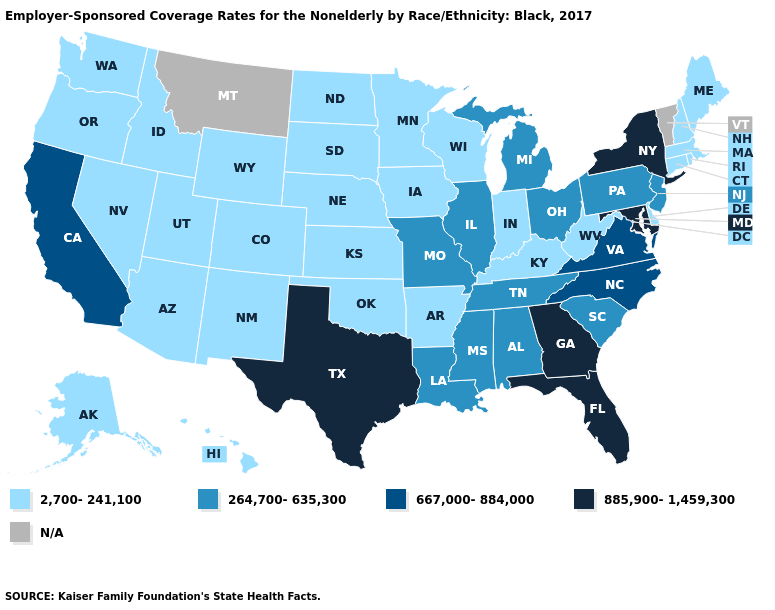Does Tennessee have the highest value in the USA?
Be succinct. No. Which states have the lowest value in the West?
Write a very short answer. Alaska, Arizona, Colorado, Hawaii, Idaho, Nevada, New Mexico, Oregon, Utah, Washington, Wyoming. Among the states that border Missouri , which have the lowest value?
Be succinct. Arkansas, Iowa, Kansas, Kentucky, Nebraska, Oklahoma. What is the lowest value in the MidWest?
Be succinct. 2,700-241,100. What is the highest value in the USA?
Concise answer only. 885,900-1,459,300. Does the map have missing data?
Concise answer only. Yes. What is the value of New Mexico?
Write a very short answer. 2,700-241,100. Among the states that border Colorado , which have the lowest value?
Be succinct. Arizona, Kansas, Nebraska, New Mexico, Oklahoma, Utah, Wyoming. Which states have the lowest value in the West?
Quick response, please. Alaska, Arizona, Colorado, Hawaii, Idaho, Nevada, New Mexico, Oregon, Utah, Washington, Wyoming. Does Colorado have the lowest value in the West?
Short answer required. Yes. Which states have the lowest value in the USA?
Keep it brief. Alaska, Arizona, Arkansas, Colorado, Connecticut, Delaware, Hawaii, Idaho, Indiana, Iowa, Kansas, Kentucky, Maine, Massachusetts, Minnesota, Nebraska, Nevada, New Hampshire, New Mexico, North Dakota, Oklahoma, Oregon, Rhode Island, South Dakota, Utah, Washington, West Virginia, Wisconsin, Wyoming. What is the value of Minnesota?
Concise answer only. 2,700-241,100. Which states hav the highest value in the South?
Short answer required. Florida, Georgia, Maryland, Texas. 